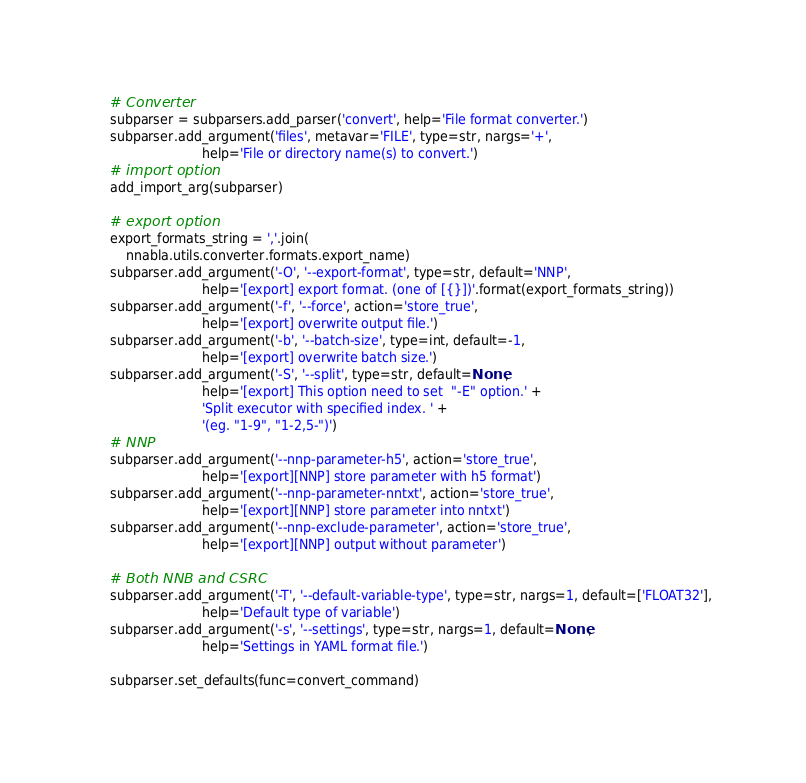Convert code to text. <code><loc_0><loc_0><loc_500><loc_500><_Python_>    # Converter
    subparser = subparsers.add_parser('convert', help='File format converter.')
    subparser.add_argument('files', metavar='FILE', type=str, nargs='+',
                           help='File or directory name(s) to convert.')
    # import option
    add_import_arg(subparser)

    # export option
    export_formats_string = ','.join(
        nnabla.utils.converter.formats.export_name)
    subparser.add_argument('-O', '--export-format', type=str, default='NNP',
                           help='[export] export format. (one of [{}])'.format(export_formats_string))
    subparser.add_argument('-f', '--force', action='store_true',
                           help='[export] overwrite output file.')
    subparser.add_argument('-b', '--batch-size', type=int, default=-1,
                           help='[export] overwrite batch size.')
    subparser.add_argument('-S', '--split', type=str, default=None,
                           help='[export] This option need to set  "-E" option.' +
                           'Split executor with specified index. ' +
                           '(eg. "1-9", "1-2,5-")')
    # NNP
    subparser.add_argument('--nnp-parameter-h5', action='store_true',
                           help='[export][NNP] store parameter with h5 format')
    subparser.add_argument('--nnp-parameter-nntxt', action='store_true',
                           help='[export][NNP] store parameter into nntxt')
    subparser.add_argument('--nnp-exclude-parameter', action='store_true',
                           help='[export][NNP] output without parameter')

    # Both NNB and CSRC
    subparser.add_argument('-T', '--default-variable-type', type=str, nargs=1, default=['FLOAT32'],
                           help='Default type of variable')
    subparser.add_argument('-s', '--settings', type=str, nargs=1, default=None,
                           help='Settings in YAML format file.')

    subparser.set_defaults(func=convert_command)
</code> 